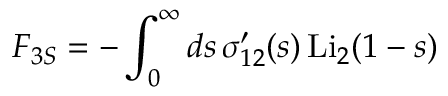<formula> <loc_0><loc_0><loc_500><loc_500>F _ { 3 S } = - \int _ { 0 } ^ { \infty } d s \, \sigma _ { 1 2 } ^ { \prime } ( s ) \, L i _ { 2 } ( 1 - s )</formula> 